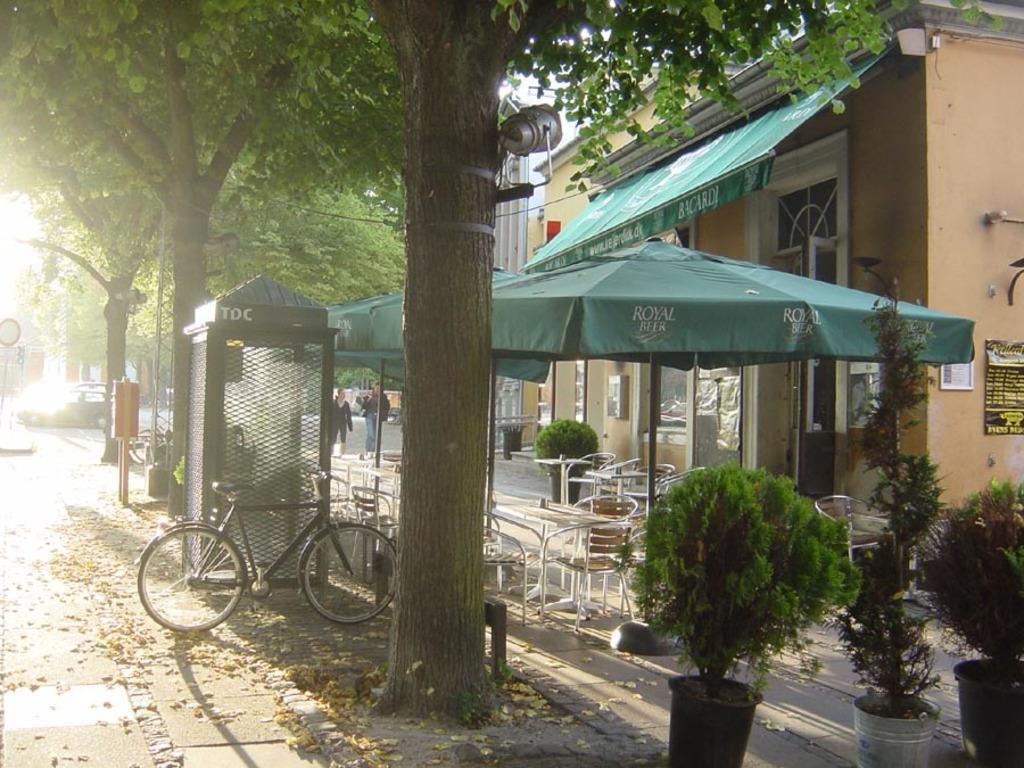How would you summarize this image in a sentence or two? On the right side of the image we can see the buildings, tents, roof, windows, chairs, tables, boards, wall. On the left side of the image we can see the traffic lights, boards, poles, road, dry leaves. In the background of the image we can see the trees, mesh, shed, bicycle, planter, pots, lights and two people are walking. At the top we can see the sky. 